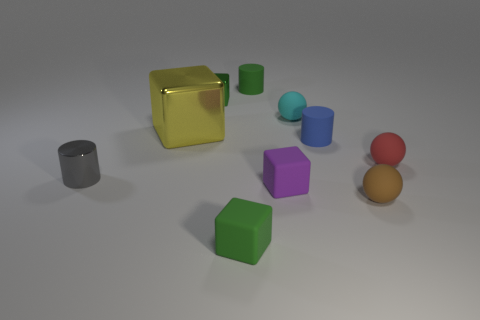Subtract all cyan blocks. Subtract all gray cylinders. How many blocks are left? 4 Subtract all cylinders. How many objects are left? 7 Subtract 0 cyan cylinders. How many objects are left? 10 Subtract all green rubber objects. Subtract all small gray objects. How many objects are left? 7 Add 1 cyan spheres. How many cyan spheres are left? 2 Add 6 green rubber objects. How many green rubber objects exist? 8 